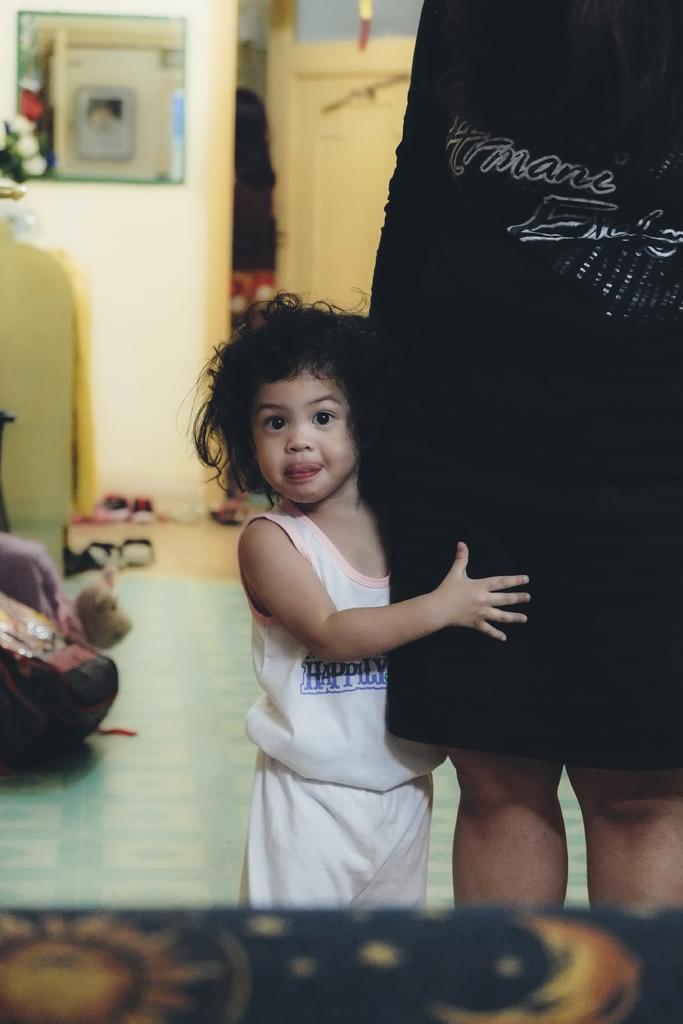In one or two sentences, can you explain what this image depicts? In this image I can see a girl and a person is standing over here. I can see she is wearing white colour dress and this person is wearing black. In the background I can see few footwear and few other things. I can also see this image is little bit blurry from background and here I can see something is written on their dresses. 